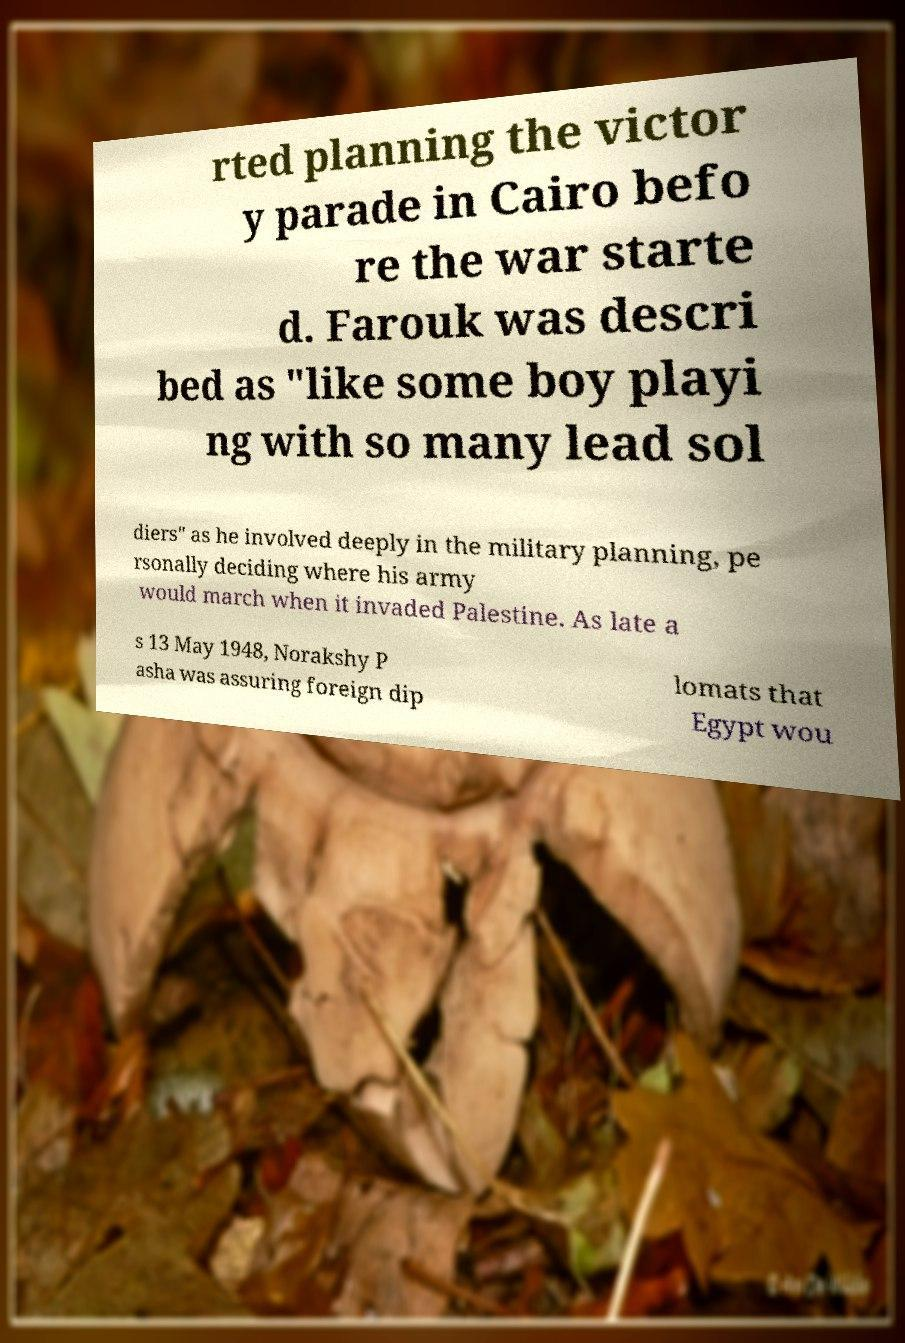For documentation purposes, I need the text within this image transcribed. Could you provide that? rted planning the victor y parade in Cairo befo re the war starte d. Farouk was descri bed as "like some boy playi ng with so many lead sol diers" as he involved deeply in the military planning, pe rsonally deciding where his army would march when it invaded Palestine. As late a s 13 May 1948, Norakshy P asha was assuring foreign dip lomats that Egypt wou 